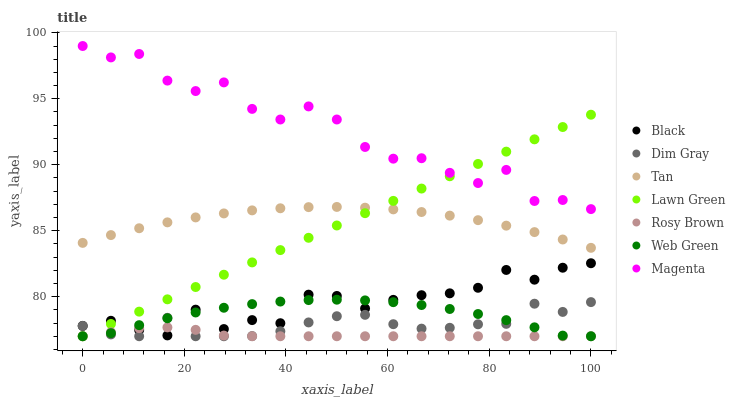Does Rosy Brown have the minimum area under the curve?
Answer yes or no. Yes. Does Magenta have the maximum area under the curve?
Answer yes or no. Yes. Does Dim Gray have the minimum area under the curve?
Answer yes or no. No. Does Dim Gray have the maximum area under the curve?
Answer yes or no. No. Is Lawn Green the smoothest?
Answer yes or no. Yes. Is Magenta the roughest?
Answer yes or no. Yes. Is Dim Gray the smoothest?
Answer yes or no. No. Is Dim Gray the roughest?
Answer yes or no. No. Does Lawn Green have the lowest value?
Answer yes or no. Yes. Does Black have the lowest value?
Answer yes or no. No. Does Magenta have the highest value?
Answer yes or no. Yes. Does Dim Gray have the highest value?
Answer yes or no. No. Is Rosy Brown less than Tan?
Answer yes or no. Yes. Is Tan greater than Dim Gray?
Answer yes or no. Yes. Does Dim Gray intersect Lawn Green?
Answer yes or no. Yes. Is Dim Gray less than Lawn Green?
Answer yes or no. No. Is Dim Gray greater than Lawn Green?
Answer yes or no. No. Does Rosy Brown intersect Tan?
Answer yes or no. No. 